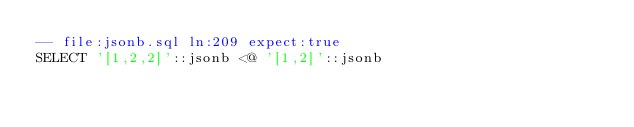Convert code to text. <code><loc_0><loc_0><loc_500><loc_500><_SQL_>-- file:jsonb.sql ln:209 expect:true
SELECT '[1,2,2]'::jsonb <@ '[1,2]'::jsonb
</code> 